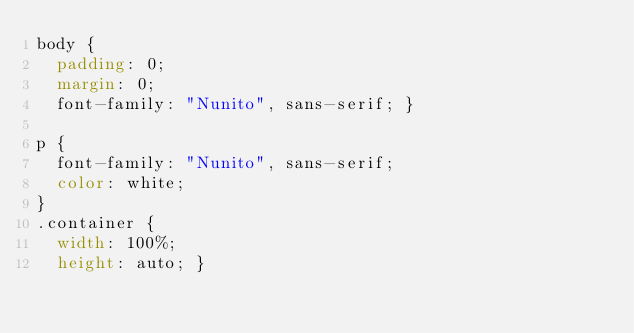Convert code to text. <code><loc_0><loc_0><loc_500><loc_500><_CSS_>body {
  padding: 0;
  margin: 0;
  font-family: "Nunito", sans-serif; }

p {
  font-family: "Nunito", sans-serif;
  color: white;
}
.container {
  width: 100%;
  height: auto; }
</code> 